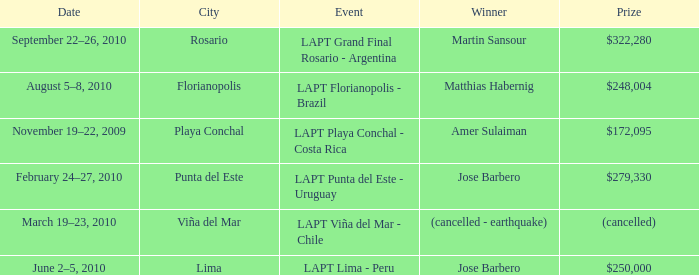What event is in florianopolis? LAPT Florianopolis - Brazil. Help me parse the entirety of this table. {'header': ['Date', 'City', 'Event', 'Winner', 'Prize'], 'rows': [['September 22–26, 2010', 'Rosario', 'LAPT Grand Final Rosario - Argentina', 'Martin Sansour', '$322,280'], ['August 5–8, 2010', 'Florianopolis', 'LAPT Florianopolis - Brazil', 'Matthias Habernig', '$248,004'], ['November 19–22, 2009', 'Playa Conchal', 'LAPT Playa Conchal - Costa Rica', 'Amer Sulaiman', '$172,095'], ['February 24–27, 2010', 'Punta del Este', 'LAPT Punta del Este - Uruguay', 'Jose Barbero', '$279,330'], ['March 19–23, 2010', 'Viña del Mar', 'LAPT Viña del Mar - Chile', '(cancelled - earthquake)', '(cancelled)'], ['June 2–5, 2010', 'Lima', 'LAPT Lima - Peru', 'Jose Barbero', '$250,000']]} 